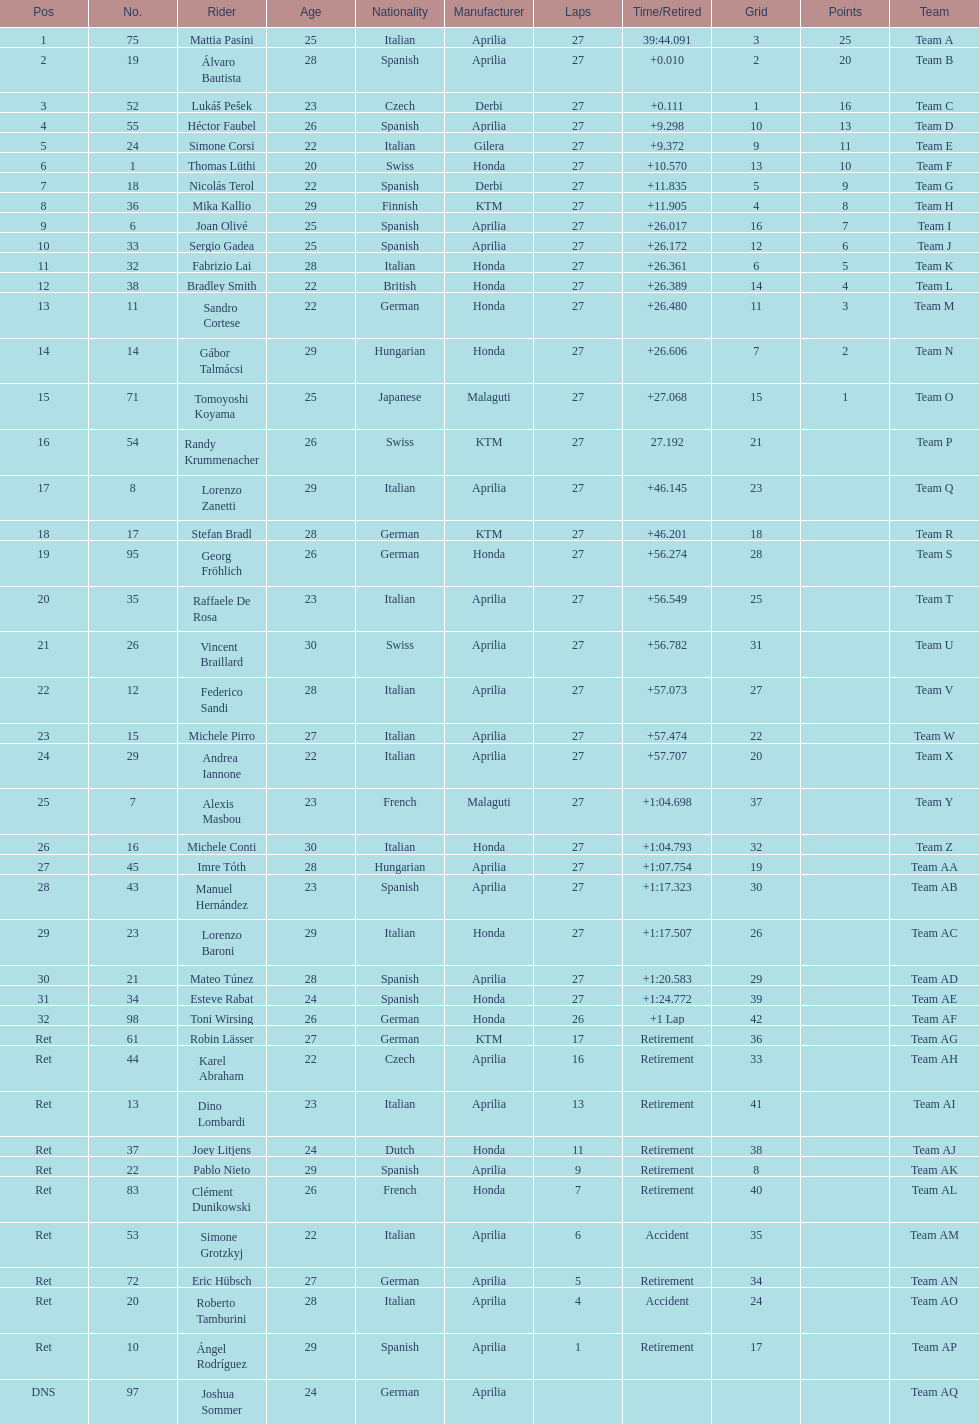I'm looking to parse the entire table for insights. Could you assist me with that? {'header': ['Pos', 'No.', 'Rider', 'Age', 'Nationality', 'Manufacturer', 'Laps', 'Time/Retired', 'Grid', 'Points', 'Team'], 'rows': [['1', '75', 'Mattia Pasini', '25', 'Italian', 'Aprilia', '27', '39:44.091', '3', '25', 'Team A'], ['2', '19', 'Álvaro Bautista', '28', 'Spanish', 'Aprilia', '27', '+0.010', '2', '20', 'Team B'], ['3', '52', 'Lukáš Pešek', '23', 'Czech', 'Derbi', '27', '+0.111', '1', '16', 'Team C'], ['4', '55', 'Héctor Faubel', '26', 'Spanish', 'Aprilia', '27', '+9.298', '10', '13', 'Team D'], ['5', '24', 'Simone Corsi', '22', 'Italian', 'Gilera', '27', '+9.372', '9', '11', 'Team E'], ['6', '1', 'Thomas Lüthi', '20', 'Swiss', 'Honda', '27', '+10.570', '13', '10', 'Team F'], ['7', '18', 'Nicolás Terol', '22', 'Spanish', 'Derbi', '27', '+11.835', '5', '9', 'Team G'], ['8', '36', 'Mika Kallio', '29', 'Finnish', 'KTM', '27', '+11.905', '4', '8', 'Team H'], ['9', '6', 'Joan Olivé', '25', 'Spanish', 'Aprilia', '27', '+26.017', '16', '7', 'Team I'], ['10', '33', 'Sergio Gadea', '25', 'Spanish', 'Aprilia', '27', '+26.172', '12', '6', 'Team J'], ['11', '32', 'Fabrizio Lai', '28', 'Italian', 'Honda', '27', '+26.361', '6', '5', 'Team K'], ['12', '38', 'Bradley Smith', '22', 'British', 'Honda', '27', '+26.389', '14', '4', 'Team L'], ['13', '11', 'Sandro Cortese', '22', 'German', 'Honda', '27', '+26.480', '11', '3', 'Team M'], ['14', '14', 'Gábor Talmácsi', '29', 'Hungarian', 'Honda', '27', '+26.606', '7', '2', 'Team N'], ['15', '71', 'Tomoyoshi Koyama', '25', 'Japanese', 'Malaguti', '27', '+27.068', '15', '1', 'Team O'], ['16', '54', 'Randy Krummenacher', '26', 'Swiss', 'KTM', '27', '27.192', '21', '', 'Team P'], ['17', '8', 'Lorenzo Zanetti', '29', 'Italian', 'Aprilia', '27', '+46.145', '23', '', 'Team Q'], ['18', '17', 'Stefan Bradl', '28', 'German', 'KTM', '27', '+46.201', '18', '', 'Team R'], ['19', '95', 'Georg Fröhlich', '26', 'German', 'Honda', '27', '+56.274', '28', '', 'Team S'], ['20', '35', 'Raffaele De Rosa', '23', 'Italian', 'Aprilia', '27', '+56.549', '25', '', 'Team T'], ['21', '26', 'Vincent Braillard', '30', 'Swiss', 'Aprilia', '27', '+56.782', '31', '', 'Team U'], ['22', '12', 'Federico Sandi', '28', 'Italian', 'Aprilia', '27', '+57.073', '27', '', 'Team V'], ['23', '15', 'Michele Pirro', '27', 'Italian', 'Aprilia', '27', '+57.474', '22', '', 'Team W'], ['24', '29', 'Andrea Iannone', '22', 'Italian', 'Aprilia', '27', '+57.707', '20', '', 'Team X'], ['25', '7', 'Alexis Masbou', '23', 'French', 'Malaguti', '27', '+1:04.698', '37', '', 'Team Y'], ['26', '16', 'Michele Conti', '30', 'Italian', 'Honda', '27', '+1:04.793', '32', '', 'Team Z'], ['27', '45', 'Imre Tóth', '28', 'Hungarian', 'Aprilia', '27', '+1:07.754', '19', '', 'Team AA'], ['28', '43', 'Manuel Hernández', '23', 'Spanish', 'Aprilia', '27', '+1:17.323', '30', '', 'Team AB'], ['29', '23', 'Lorenzo Baroni', '29', 'Italian', 'Honda', '27', '+1:17.507', '26', '', 'Team AC'], ['30', '21', 'Mateo Túnez', '28', 'Spanish', 'Aprilia', '27', '+1:20.583', '29', '', 'Team AD'], ['31', '34', 'Esteve Rabat', '24', 'Spanish', 'Honda', '27', '+1:24.772', '39', '', 'Team AE'], ['32', '98', 'Toni Wirsing', '26', 'German', 'Honda', '26', '+1 Lap', '42', '', 'Team AF'], ['Ret', '61', 'Robin Lässer', '27', 'German', 'KTM', '17', 'Retirement', '36', '', 'Team AG'], ['Ret', '44', 'Karel Abraham', '22', 'Czech', 'Aprilia', '16', 'Retirement', '33', '', 'Team AH'], ['Ret', '13', 'Dino Lombardi', '23', 'Italian', 'Aprilia', '13', 'Retirement', '41', '', 'Team AI'], ['Ret', '37', 'Joey Litjens', '24', 'Dutch', 'Honda', '11', 'Retirement', '38', '', 'Team AJ'], ['Ret', '22', 'Pablo Nieto', '29', 'Spanish', 'Aprilia', '9', 'Retirement', '8', '', 'Team AK'], ['Ret', '83', 'Clément Dunikowski', '26', 'French', 'Honda', '7', 'Retirement', '40', '', 'Team AL'], ['Ret', '53', 'Simone Grotzkyj', '22', 'Italian', 'Aprilia', '6', 'Accident', '35', '', 'Team AM'], ['Ret', '72', 'Eric Hübsch', '27', 'German', 'Aprilia', '5', 'Retirement', '34', '', 'Team AN'], ['Ret', '20', 'Roberto Tamburini', '28', 'Italian', 'Aprilia', '4', 'Accident', '24', '', 'Team AO'], ['Ret', '10', 'Ángel Rodríguez', '29', 'Spanish', 'Aprilia', '1', 'Retirement', '17', '', 'Team AP'], ['DNS', '97', 'Joshua Sommer', '24', 'German', 'Aprilia', '', '', '', '', 'Team AQ']]} How many racers did not use an aprilia or a honda? 9. 